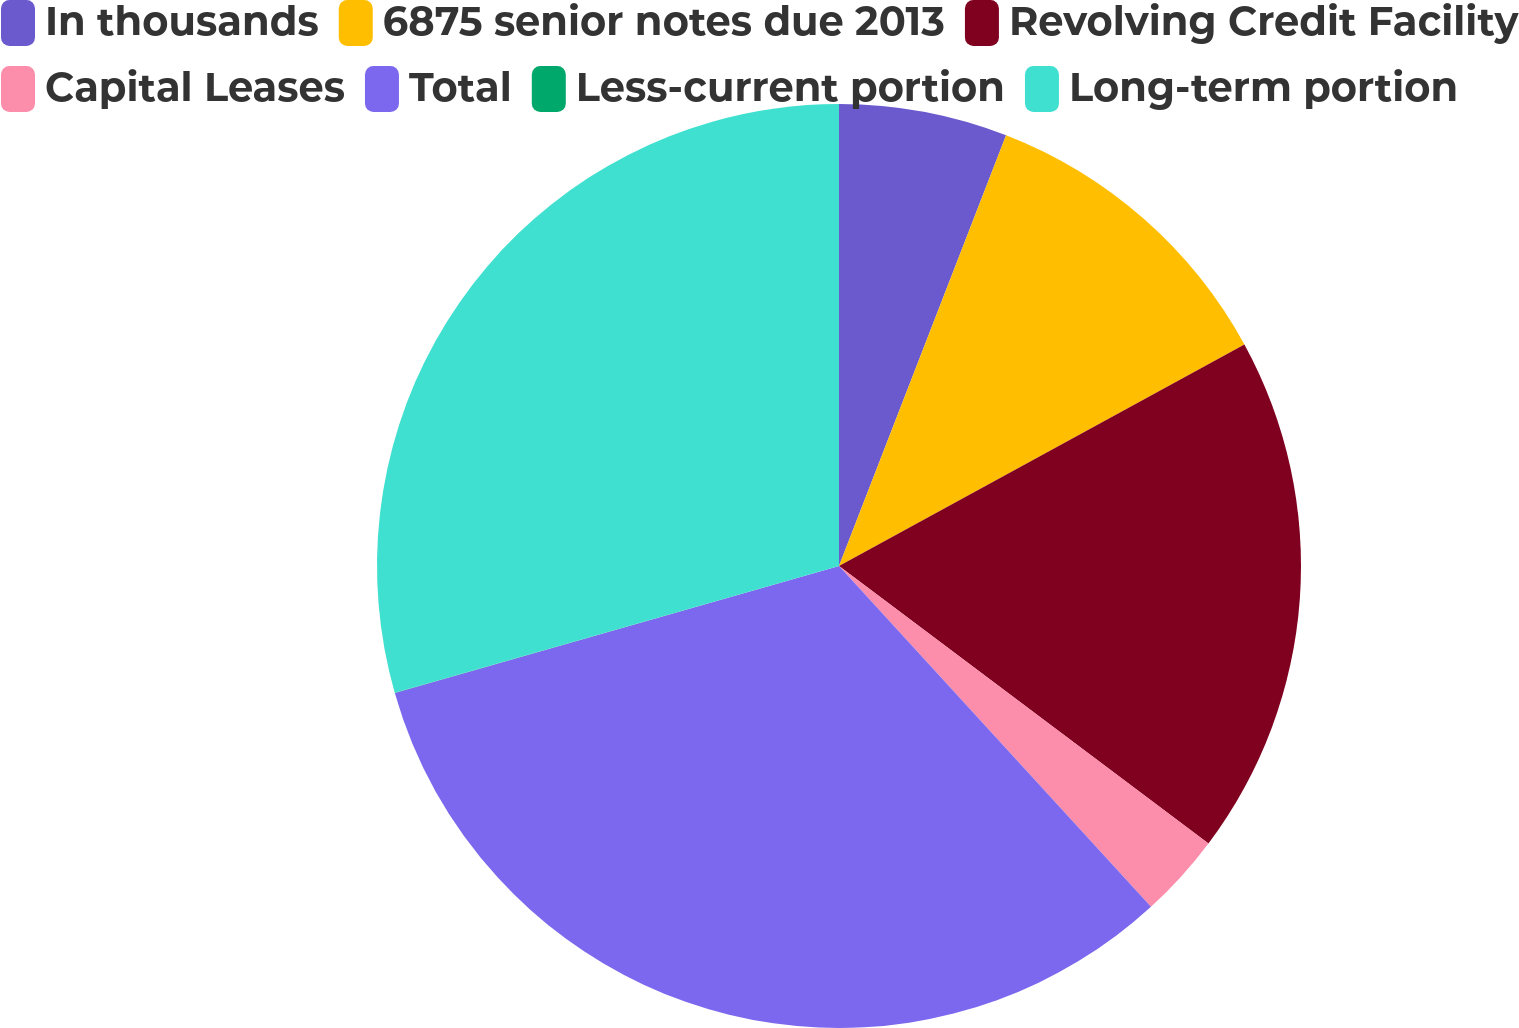Convert chart. <chart><loc_0><loc_0><loc_500><loc_500><pie_chart><fcel>In thousands<fcel>6875 senior notes due 2013<fcel>Revolving Credit Facility<fcel>Capital Leases<fcel>Total<fcel>Less-current portion<fcel>Long-term portion<nl><fcel>5.89%<fcel>11.15%<fcel>18.21%<fcel>2.95%<fcel>32.37%<fcel>0.01%<fcel>29.42%<nl></chart> 